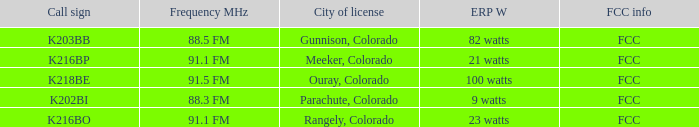Which erp w possesses a frequency mhz of 8 82 watts. 